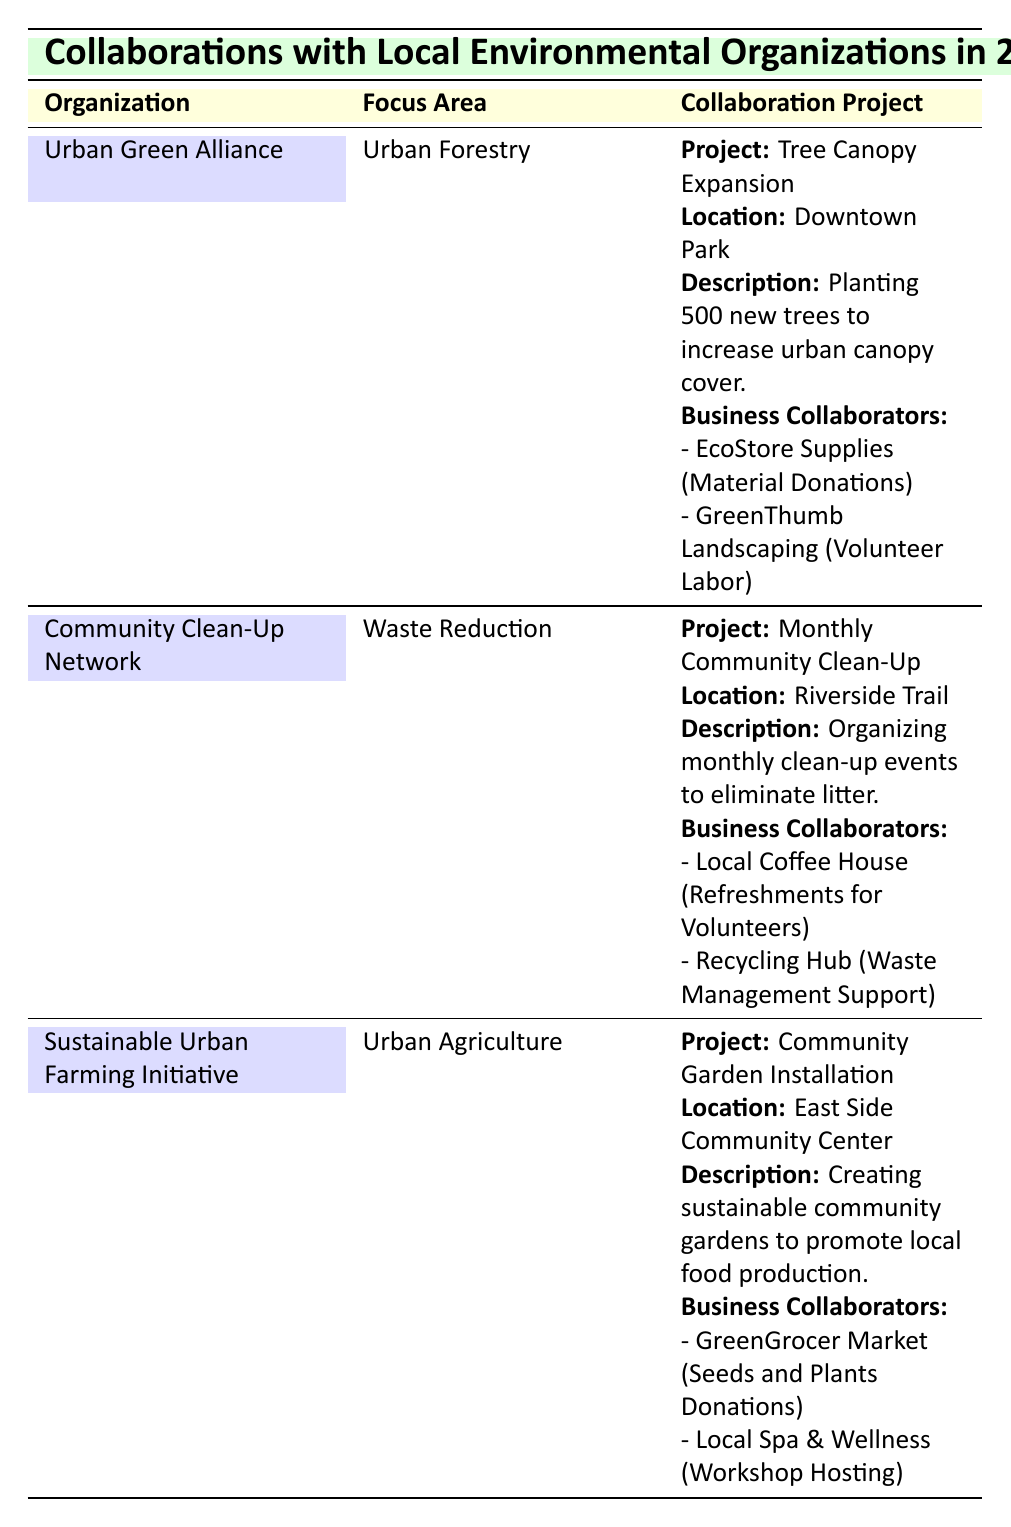What is the focus area of the Urban Green Alliance? The focus area for the Urban Green Alliance is listed in the table under the "Focus Area" column, which clearly states "Urban Forestry."
Answer: Urban Forestry Which project did the Community Clean-Up Network collaborate on in 2023? The table shows that the Community Clean-Up Network collaborated on the "Monthly Community Clean-Up" project in 2023, which is labeled specifically within the "Collaboration Project" section.
Answer: Monthly Community Clean-Up How many total business collaborators are involved in the Sustainable Urban Farming Initiative projects? The Sustainable Urban Farming Initiative has listed two business collaborators for its project: GreenGrocer Market and Local Spa & Wellness. Since there are no other projects listed, the total count is 2.
Answer: 2 Is the contribution type of EcoStore Supplies material donations? The table specifically notes that EcoStore Supplies contributes "Material Donations" for the Urban Green Alliance's "Tree Canopy Expansion" project, confirming this fact.
Answer: Yes Which organization focuses on urban agriculture and what project do they support? The table shows that the organization focusing on urban agriculture is the Sustainable Urban Farming Initiative, and they support the project named "Community Garden Installation." This involves creating sustainable community gardens.
Answer: Sustainable Urban Farming Initiative; Community Garden Installation What is the location of the project organized by the Community Clean-Up Network? According to the table, the location of the project "Monthly Community Clean-Up" organized by the Community Clean-Up Network is "Riverside Trail." This information is clearly outlined in the location section of the collaboration project details.
Answer: Riverside Trail How many projects are organized by Urban Green Alliance in 2023? The table indicates that the Urban Green Alliance is involved in one project, the "Tree Canopy Expansion," which is the only project listed under their section for the year 2023.
Answer: 1 Which business is providing refreshments for the volunteers in the Community Clean-Up project? The table lists the Local Coffee House as the business providing "Refreshments for Volunteers" for the project organized by the Community Clean-Up Network. This collaboration is explicitly described in the project's details.
Answer: Local Coffee House Do both the Urban Green Alliance and the Sustainable Urban Farming Initiative have projects that include business collaborations? Yes, both organizations listed (Urban Green Alliance and Sustainable Urban Farming Initiative) have projects that include business collaborations, as specifically noted in the business collaborators section for each project.
Answer: Yes 